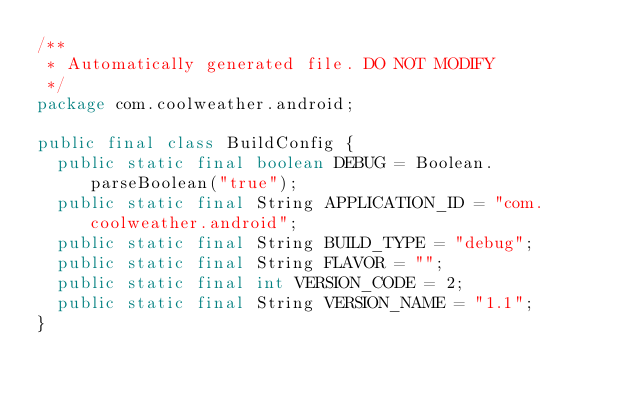Convert code to text. <code><loc_0><loc_0><loc_500><loc_500><_Java_>/**
 * Automatically generated file. DO NOT MODIFY
 */
package com.coolweather.android;

public final class BuildConfig {
  public static final boolean DEBUG = Boolean.parseBoolean("true");
  public static final String APPLICATION_ID = "com.coolweather.android";
  public static final String BUILD_TYPE = "debug";
  public static final String FLAVOR = "";
  public static final int VERSION_CODE = 2;
  public static final String VERSION_NAME = "1.1";
}
</code> 